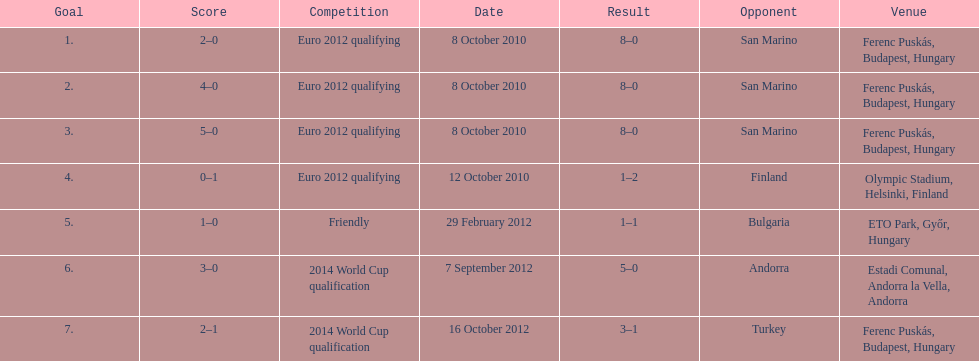Parse the full table. {'header': ['Goal', 'Score', 'Competition', 'Date', 'Result', 'Opponent', 'Venue'], 'rows': [['1.', '2–0', 'Euro 2012 qualifying', '8 October 2010', '8–0', 'San Marino', 'Ferenc Puskás, Budapest, Hungary'], ['2.', '4–0', 'Euro 2012 qualifying', '8 October 2010', '8–0', 'San Marino', 'Ferenc Puskás, Budapest, Hungary'], ['3.', '5–0', 'Euro 2012 qualifying', '8 October 2010', '8–0', 'San Marino', 'Ferenc Puskás, Budapest, Hungary'], ['4.', '0–1', 'Euro 2012 qualifying', '12 October 2010', '1–2', 'Finland', 'Olympic Stadium, Helsinki, Finland'], ['5.', '1–0', 'Friendly', '29 February 2012', '1–1', 'Bulgaria', 'ETO Park, Győr, Hungary'], ['6.', '3–0', '2014 World Cup qualification', '7 September 2012', '5–0', 'Andorra', 'Estadi Comunal, Andorra la Vella, Andorra'], ['7.', '2–1', '2014 World Cup qualification', '16 October 2012', '3–1', 'Turkey', 'Ferenc Puskás, Budapest, Hungary']]} In what year did ádám szalai make his next international goal after 2010? 2012. 